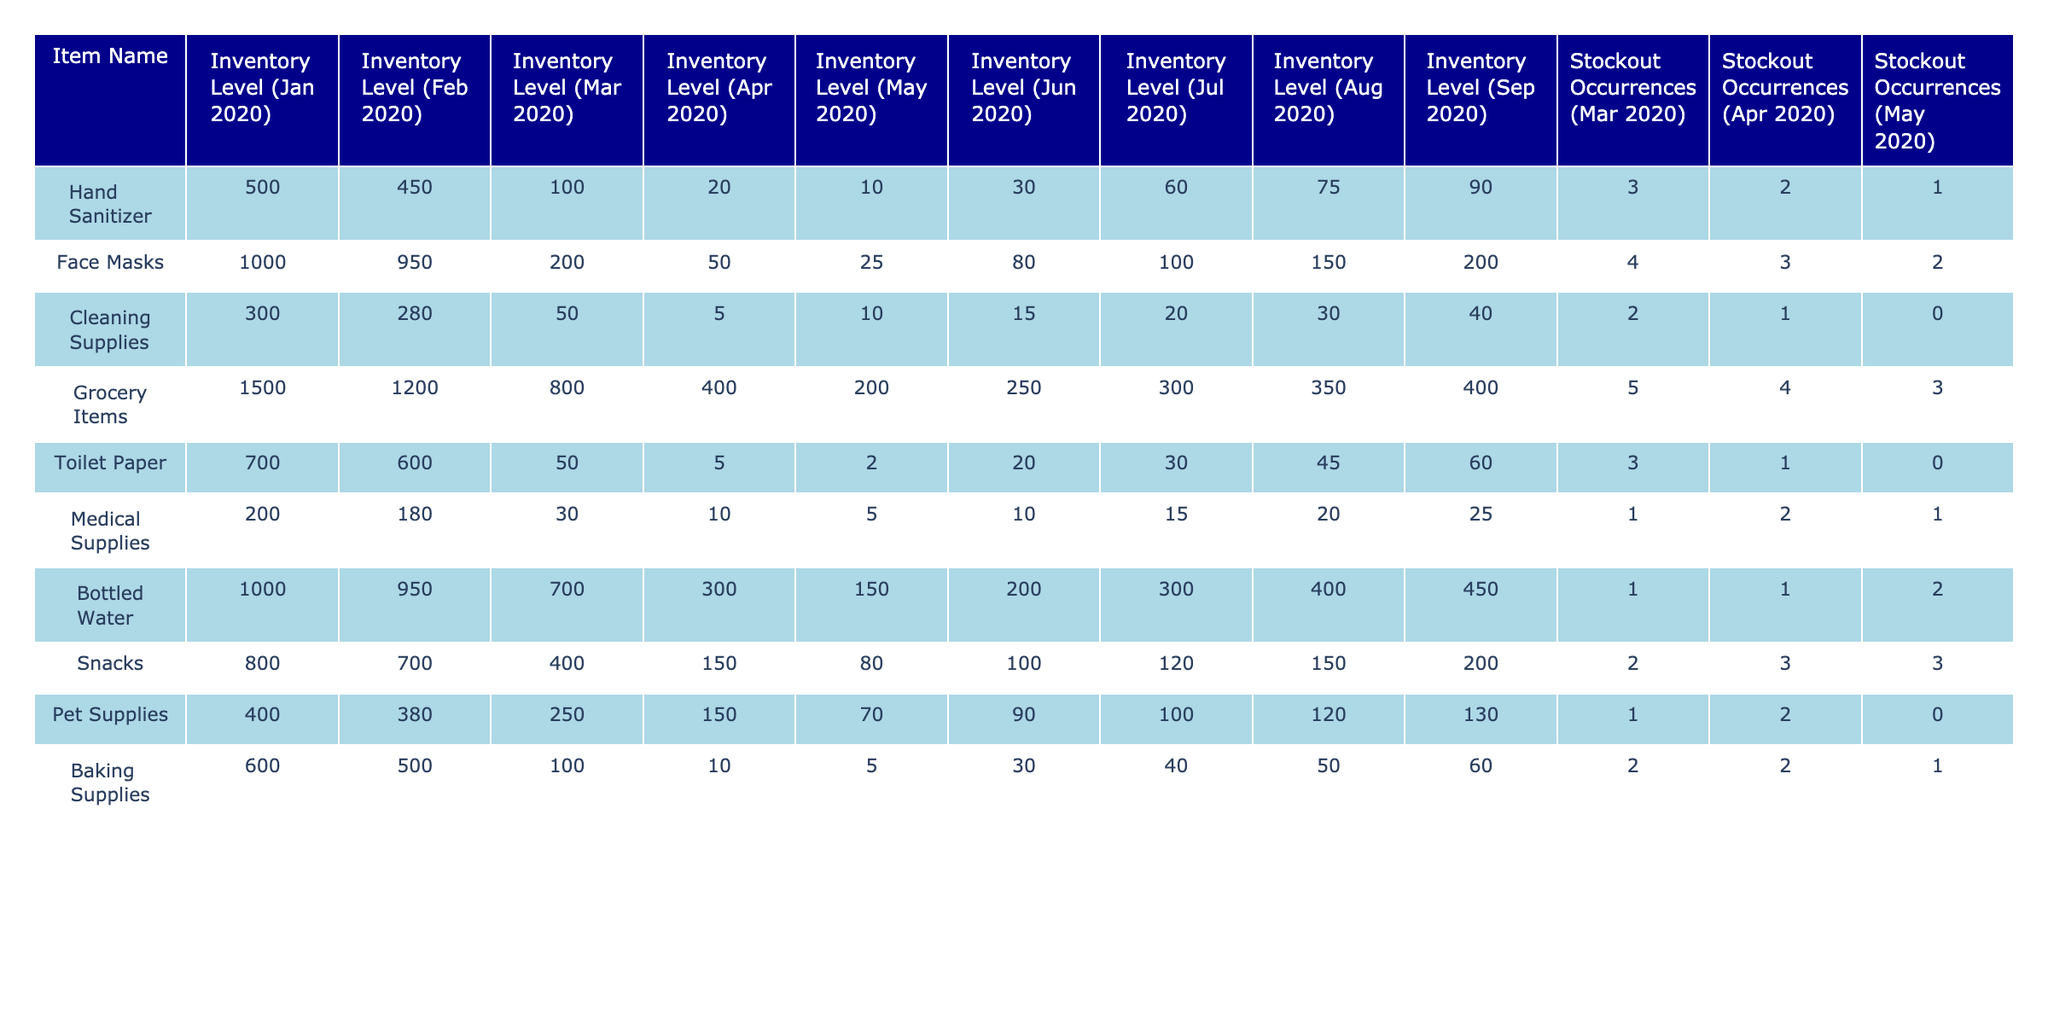What was the inventory level of hand sanitizer in June 2020? The table shows that the inventory level of hand sanitizer in June 2020 was 30.
Answer: 30 Which item had the highest number of stockout occurrences in March 2020? By looking at the stockout occurrences for each item in March 2020, Face Masks have the highest at 4 occurrences.
Answer: Face Masks What is the difference in inventory levels of grocery items between February 2020 and September 2020? The inventory level of grocery items in February 2020 was 1200, and in September 2020 it was 400. The difference is 1200 - 400 = 800.
Answer: 800 Did any item run out of stock completely in May 2020? Checking the stockout occurrences for May 2020, Cleaning Supplies shows 0 occurrences, meaning it did not run out of stock.
Answer: Yes What was the total number of stockouts for cleaning supplies across all months recorded? Adding the stockout occurrences for cleaning supplies: 2 (March) + 1 (April) + 0 (May) gives a total of 3 stockouts.
Answer: 3 Which item had the lowest inventory level in April 2020? Looking at the inventory levels in April 2020: Hand Sanitizer (20), Face Masks (50), Cleaning Supplies (5), Grocery Items (400), Toilet Paper (5), Medical Supplies (10), Bottled Water (300), Snacks (150), Pet Supplies (150), Baking Supplies (10). Both Cleaning Supplies and Toilet Paper are tied at the lowest level of 5.
Answer: Cleaning Supplies and Toilet Paper What was the average number of stockouts across all items in April 2020? The stockout occurrences in April 2020 are: 2 (Hand Sanitizer), 3 (Face Masks), 1 (Cleaning Supplies), 4 (Grocery Items), 1 (Toilet Paper), 2 (Medical Supplies), 1 (Bottled Water), 3 (Snacks), 2 (Pet Supplies), 2 (Baking Supplies), which totals to 19 stockouts. There are 10 items, so the average is 19 / 10 = 1.9.
Answer: 1.9 In which month did bottled water have its maximum inventory level? The inventory levels for bottled water were: 1000 (Jan), 950 (Feb), 700 (Mar), 300 (Apr), 150 (May), 200 (Jun), 300 (Jul), 400 (Aug), 450 (Sep), so the maximum is 1000 in January.
Answer: January What was the change in inventory level for pet supplies from January 2020 to July 2020? The inventory level for pet supplies in January 2020 was 400 and in July 2020 it was 100. The change is 400 - 100 = 300.
Answer: 300 Was there any month in which the inventory level of snacks was higher than that of toilet paper? In all months recorded, snacks had higher inventory levels than toilet paper: 800 (Snacks) vs 700 (Toilet Paper) in Jan, 700 vs 600 in Feb, 400 vs 50 in Mar, and similarly in Apr and later months.
Answer: Yes 